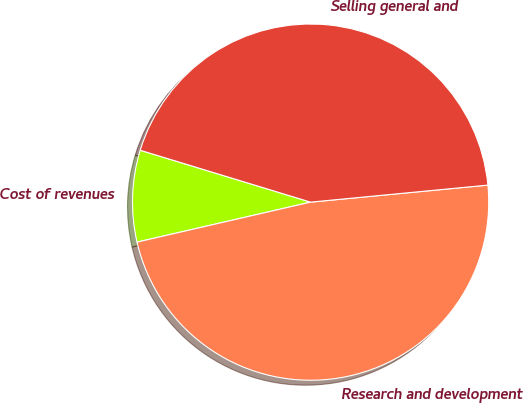Convert chart to OTSL. <chart><loc_0><loc_0><loc_500><loc_500><pie_chart><fcel>Cost of revenues<fcel>Research and development<fcel>Selling general and<nl><fcel>8.31%<fcel>47.92%<fcel>43.77%<nl></chart> 